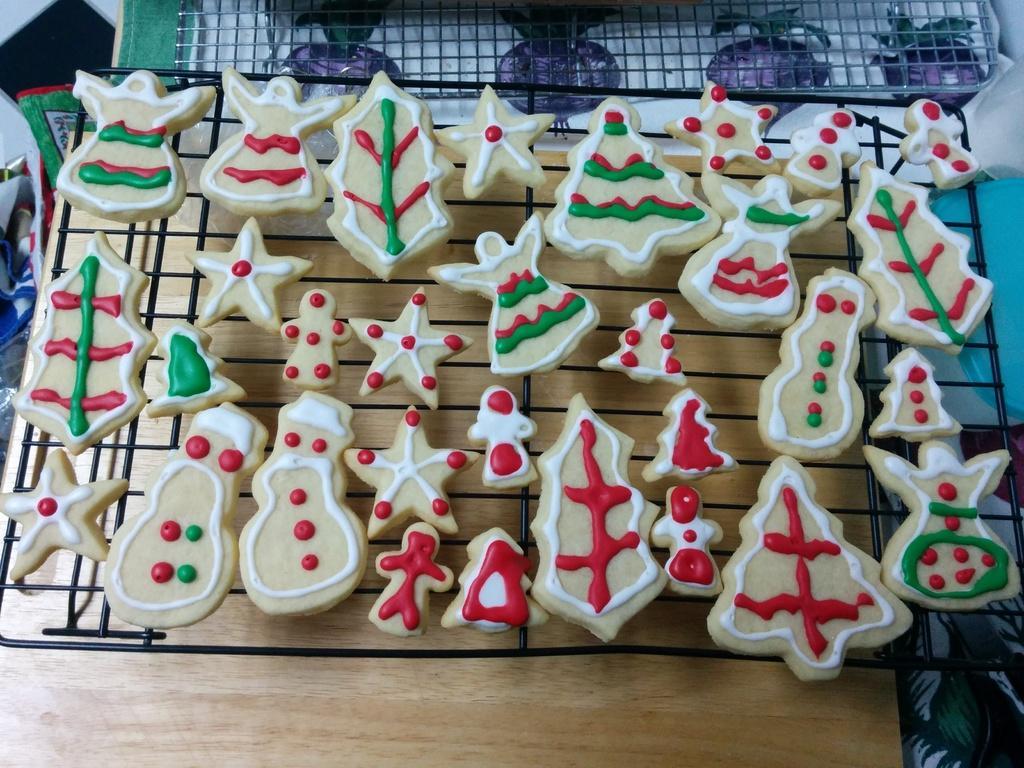Please provide a concise description of this image. In this image I can see few food items on the grill and the food is in brown, white, red and green color. The grill is on the brown color surface. I can see few objects around. 